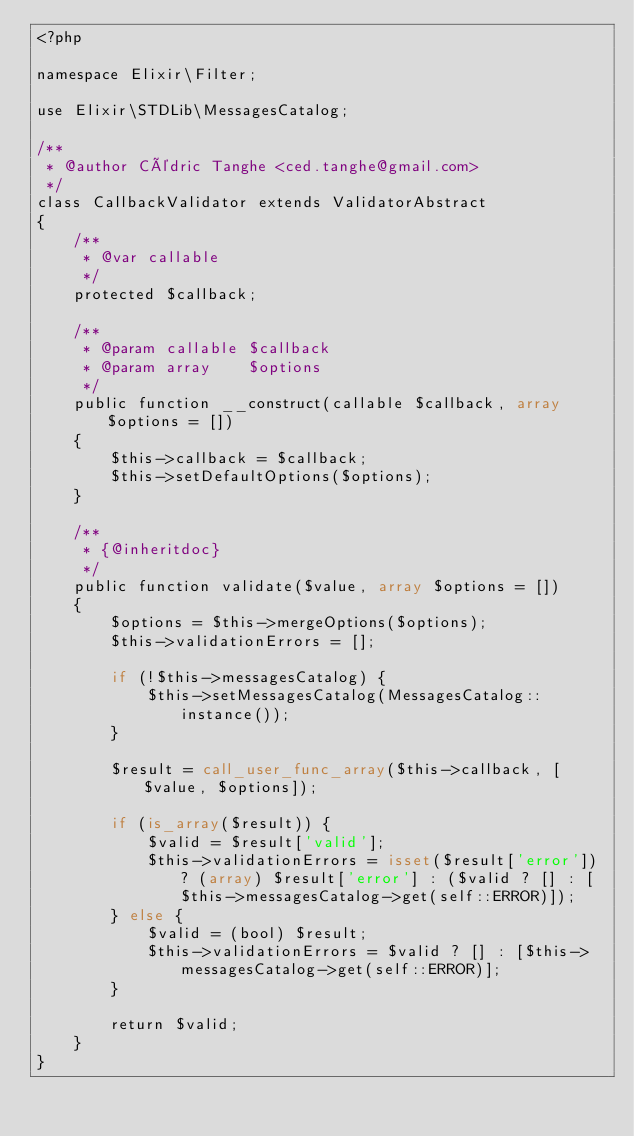Convert code to text. <code><loc_0><loc_0><loc_500><loc_500><_PHP_><?php

namespace Elixir\Filter;

use Elixir\STDLib\MessagesCatalog;

/**
 * @author Cédric Tanghe <ced.tanghe@gmail.com>
 */
class CallbackValidator extends ValidatorAbstract
{
    /**
     * @var callable
     */
    protected $callback;

    /**
     * @param callable $callback
     * @param array    $options
     */
    public function __construct(callable $callback, array $options = [])
    {
        $this->callback = $callback;
        $this->setDefaultOptions($options);
    }

    /**
     * {@inheritdoc}
     */
    public function validate($value, array $options = [])
    {
        $options = $this->mergeOptions($options);
        $this->validationErrors = [];

        if (!$this->messagesCatalog) {
            $this->setMessagesCatalog(MessagesCatalog::instance());
        }

        $result = call_user_func_array($this->callback, [$value, $options]);

        if (is_array($result)) {
            $valid = $result['valid'];
            $this->validationErrors = isset($result['error']) ? (array) $result['error'] : ($valid ? [] : [$this->messagesCatalog->get(self::ERROR)]);
        } else {
            $valid = (bool) $result;
            $this->validationErrors = $valid ? [] : [$this->messagesCatalog->get(self::ERROR)];
        }

        return $valid;
    }
}
</code> 